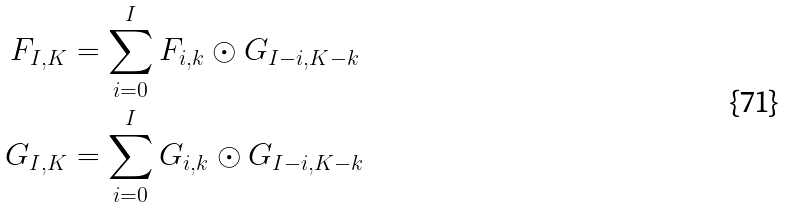Convert formula to latex. <formula><loc_0><loc_0><loc_500><loc_500>F _ { I , K } & = \sum _ { i = 0 } ^ { I } F _ { i , k } \odot G _ { I - i , K - k } \\ G _ { I , K } & = \sum _ { i = 0 } ^ { I } G _ { i , k } \odot G _ { I - i , K - k }</formula> 